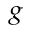<formula> <loc_0><loc_0><loc_500><loc_500>_ { g }</formula> 